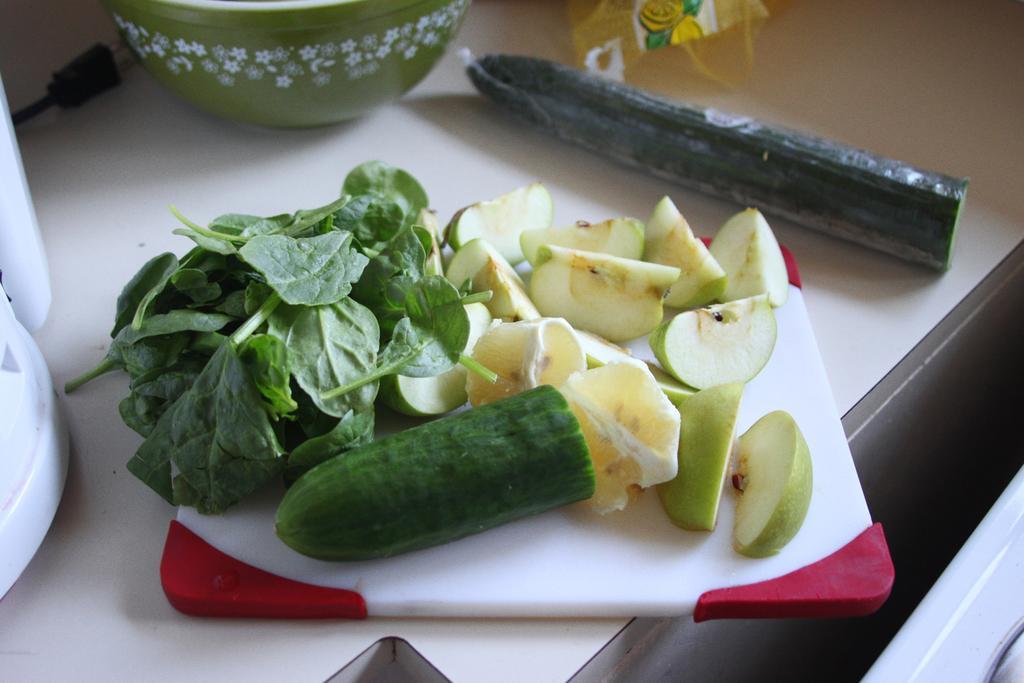Describe this image in one or two sentences. In this image there is a bowl, cutting pad, fruits, vegetables and objects are on the table. 